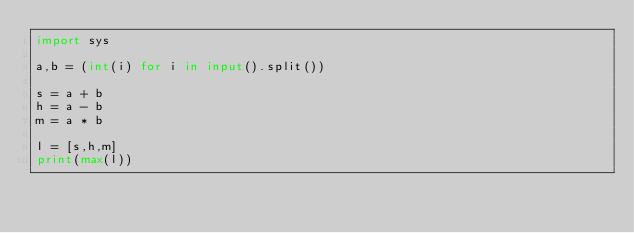<code> <loc_0><loc_0><loc_500><loc_500><_Python_>import sys

a,b = (int(i) for i in input().split())

s = a + b
h = a - b
m = a * b

l = [s,h,m]
print(max(l))</code> 